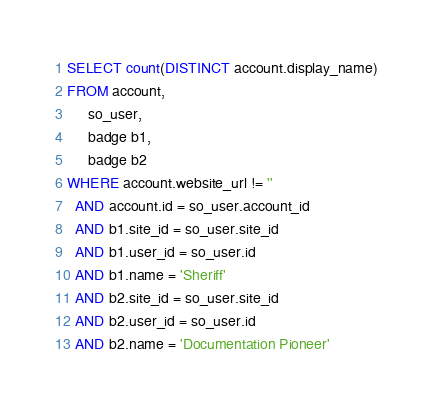Convert code to text. <code><loc_0><loc_0><loc_500><loc_500><_SQL_>
SELECT count(DISTINCT account.display_name)
FROM account,
     so_user,
     badge b1,
     badge b2
WHERE account.website_url != ''
  AND account.id = so_user.account_id
  AND b1.site_id = so_user.site_id
  AND b1.user_id = so_user.id
  AND b1.name = 'Sheriff'
  AND b2.site_id = so_user.site_id
  AND b2.user_id = so_user.id
  AND b2.name = 'Documentation Pioneer'</code> 